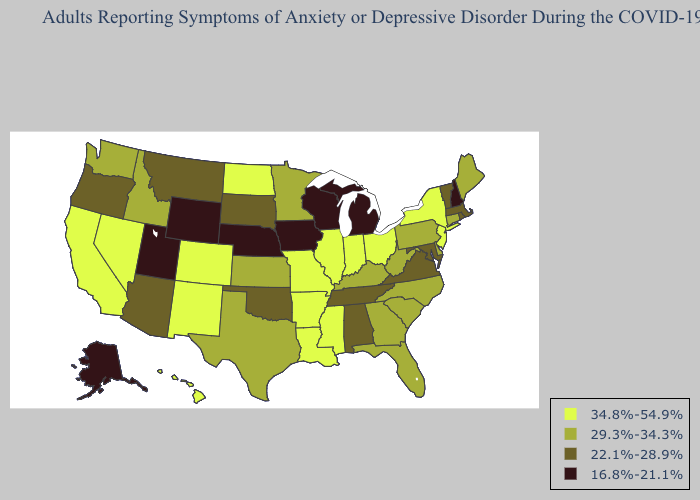Name the states that have a value in the range 29.3%-34.3%?
Keep it brief. Connecticut, Delaware, Florida, Georgia, Idaho, Kansas, Kentucky, Maine, Minnesota, North Carolina, Pennsylvania, South Carolina, Texas, Washington, West Virginia. Among the states that border Minnesota , does South Dakota have the lowest value?
Quick response, please. No. What is the highest value in states that border Indiana?
Be succinct. 34.8%-54.9%. What is the highest value in the USA?
Short answer required. 34.8%-54.9%. What is the lowest value in states that border Ohio?
Concise answer only. 16.8%-21.1%. Name the states that have a value in the range 16.8%-21.1%?
Write a very short answer. Alaska, Iowa, Michigan, Nebraska, New Hampshire, Utah, Wisconsin, Wyoming. Name the states that have a value in the range 16.8%-21.1%?
Quick response, please. Alaska, Iowa, Michigan, Nebraska, New Hampshire, Utah, Wisconsin, Wyoming. Does Massachusetts have the same value as Georgia?
Write a very short answer. No. Name the states that have a value in the range 22.1%-28.9%?
Give a very brief answer. Alabama, Arizona, Maryland, Massachusetts, Montana, Oklahoma, Oregon, Rhode Island, South Dakota, Tennessee, Vermont, Virginia. Does Hawaii have a lower value than Nevada?
Give a very brief answer. No. What is the value of Nebraska?
Give a very brief answer. 16.8%-21.1%. Name the states that have a value in the range 29.3%-34.3%?
Be succinct. Connecticut, Delaware, Florida, Georgia, Idaho, Kansas, Kentucky, Maine, Minnesota, North Carolina, Pennsylvania, South Carolina, Texas, Washington, West Virginia. Name the states that have a value in the range 16.8%-21.1%?
Keep it brief. Alaska, Iowa, Michigan, Nebraska, New Hampshire, Utah, Wisconsin, Wyoming. Among the states that border Florida , which have the lowest value?
Keep it brief. Alabama. Does New Hampshire have the lowest value in the Northeast?
Short answer required. Yes. 